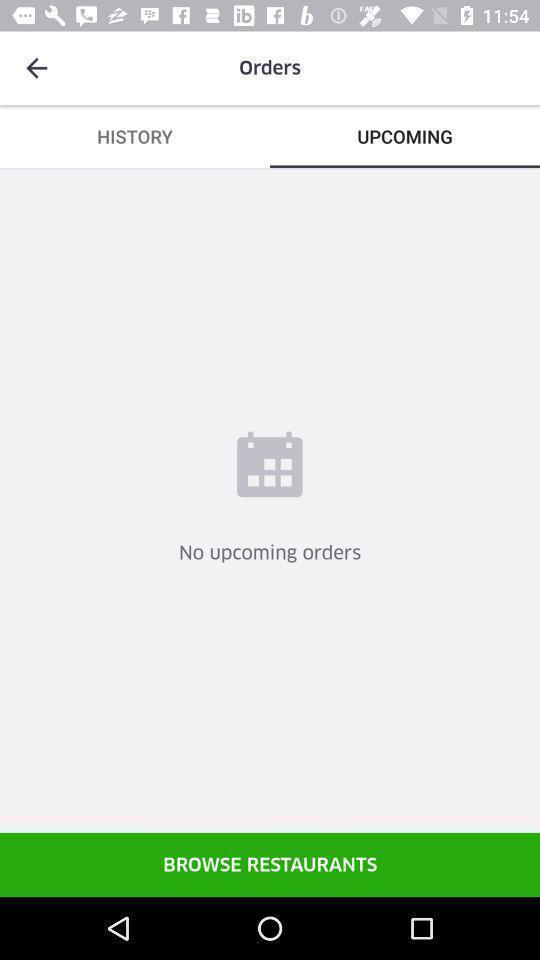Describe the visual elements of this screenshot. Screen showing upcoming orders page. 